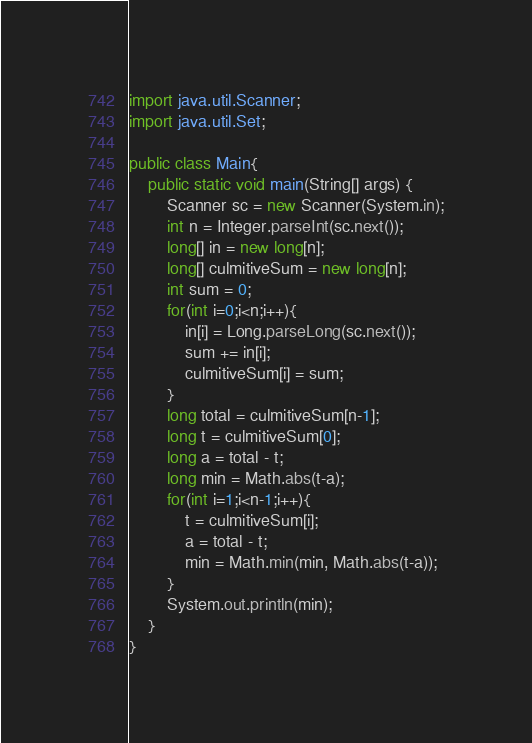<code> <loc_0><loc_0><loc_500><loc_500><_Java_>import java.util.Scanner;
import java.util.Set;

public class Main{
    public static void main(String[] args) {
        Scanner sc = new Scanner(System.in);
        int n = Integer.parseInt(sc.next());
        long[] in = new long[n];
        long[] culmitiveSum = new long[n];
        int sum = 0;
        for(int i=0;i<n;i++){
            in[i] = Long.parseLong(sc.next());
            sum += in[i];
            culmitiveSum[i] = sum;
        }
        long total = culmitiveSum[n-1];
        long t = culmitiveSum[0];
        long a = total - t;
        long min = Math.abs(t-a);
        for(int i=1;i<n-1;i++){
            t = culmitiveSum[i];
            a = total - t;
            min = Math.min(min, Math.abs(t-a));
        }
        System.out.println(min);
    }
}</code> 